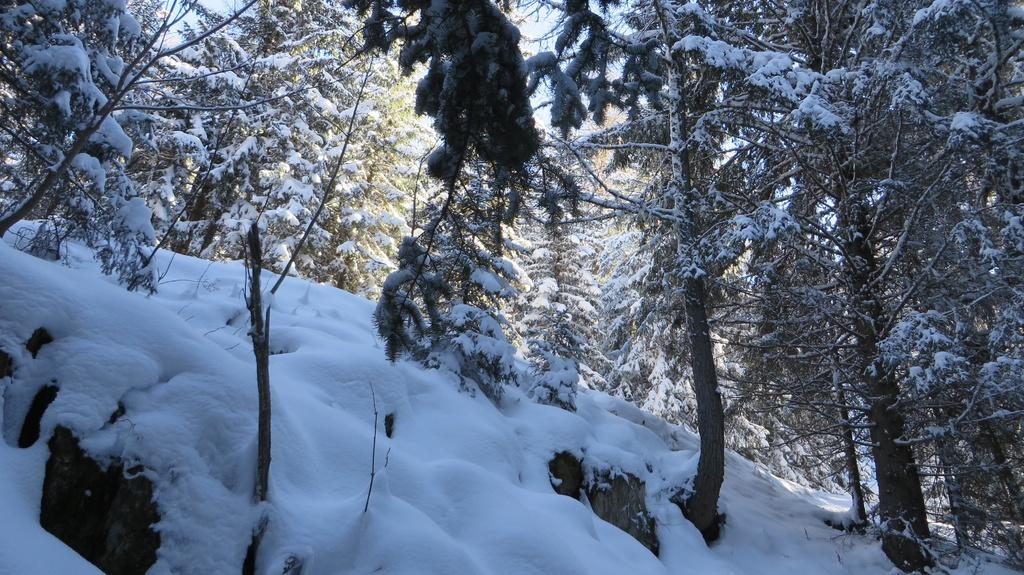What type of terrain is depicted in the image? There is a slope of a hill in the image. What is the condition of the hill in the image? The hill is covered with snow. Are there any plants visible on the hill? Yes, there are trees on the hill. How does the snow appear on the hill? There is snow on the hill. What is the historical significance of the park in the image? There is no park present in the image; it features a snow-covered hill with trees. What scent can be detected from the image? The image does not convey any scents, as it is a visual representation. 